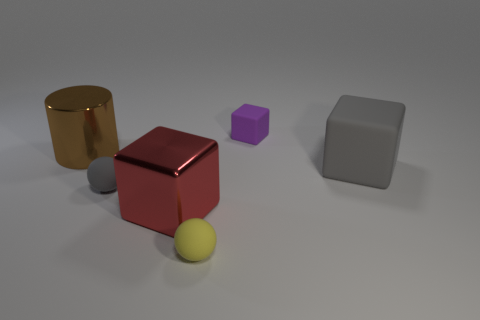Subtract all large cubes. How many cubes are left? 1 Subtract 1 cubes. How many cubes are left? 2 Add 3 large gray rubber cubes. How many objects exist? 9 Subtract all cyan blocks. Subtract all gray cylinders. How many blocks are left? 3 Subtract all balls. How many objects are left? 4 Add 6 small purple metal objects. How many small purple metal objects exist? 6 Subtract 0 yellow cubes. How many objects are left? 6 Subtract all large brown metal spheres. Subtract all cylinders. How many objects are left? 5 Add 1 yellow rubber objects. How many yellow rubber objects are left? 2 